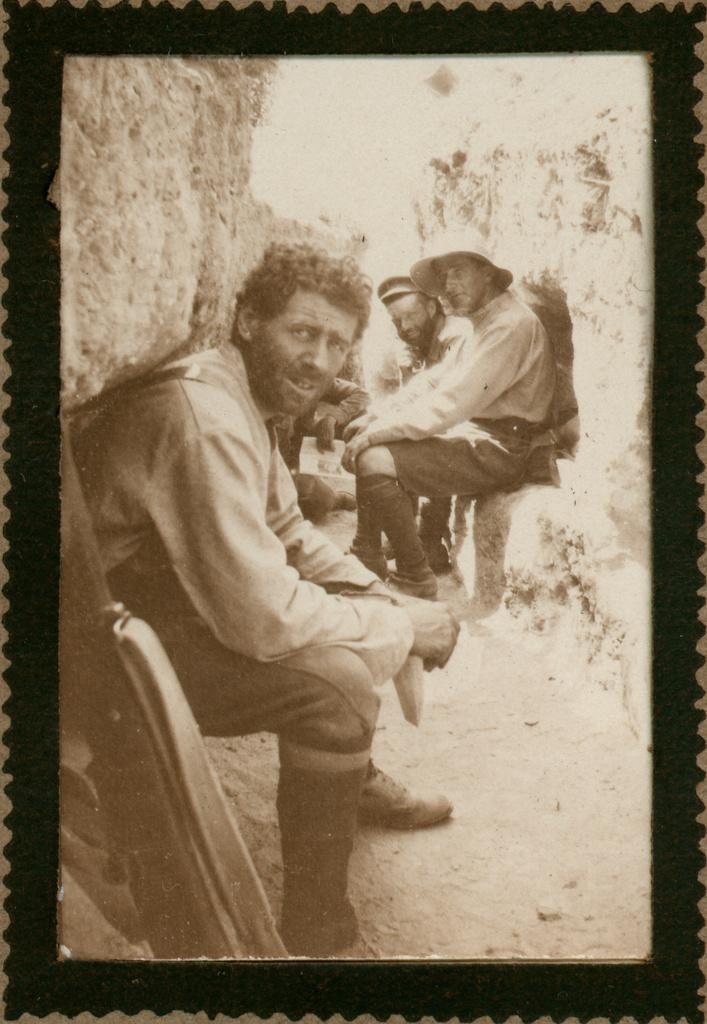How would you summarize this image in a sentence or two? In this edited image, we can see people wearing clothes. There is an object in the bottom left of the image. 